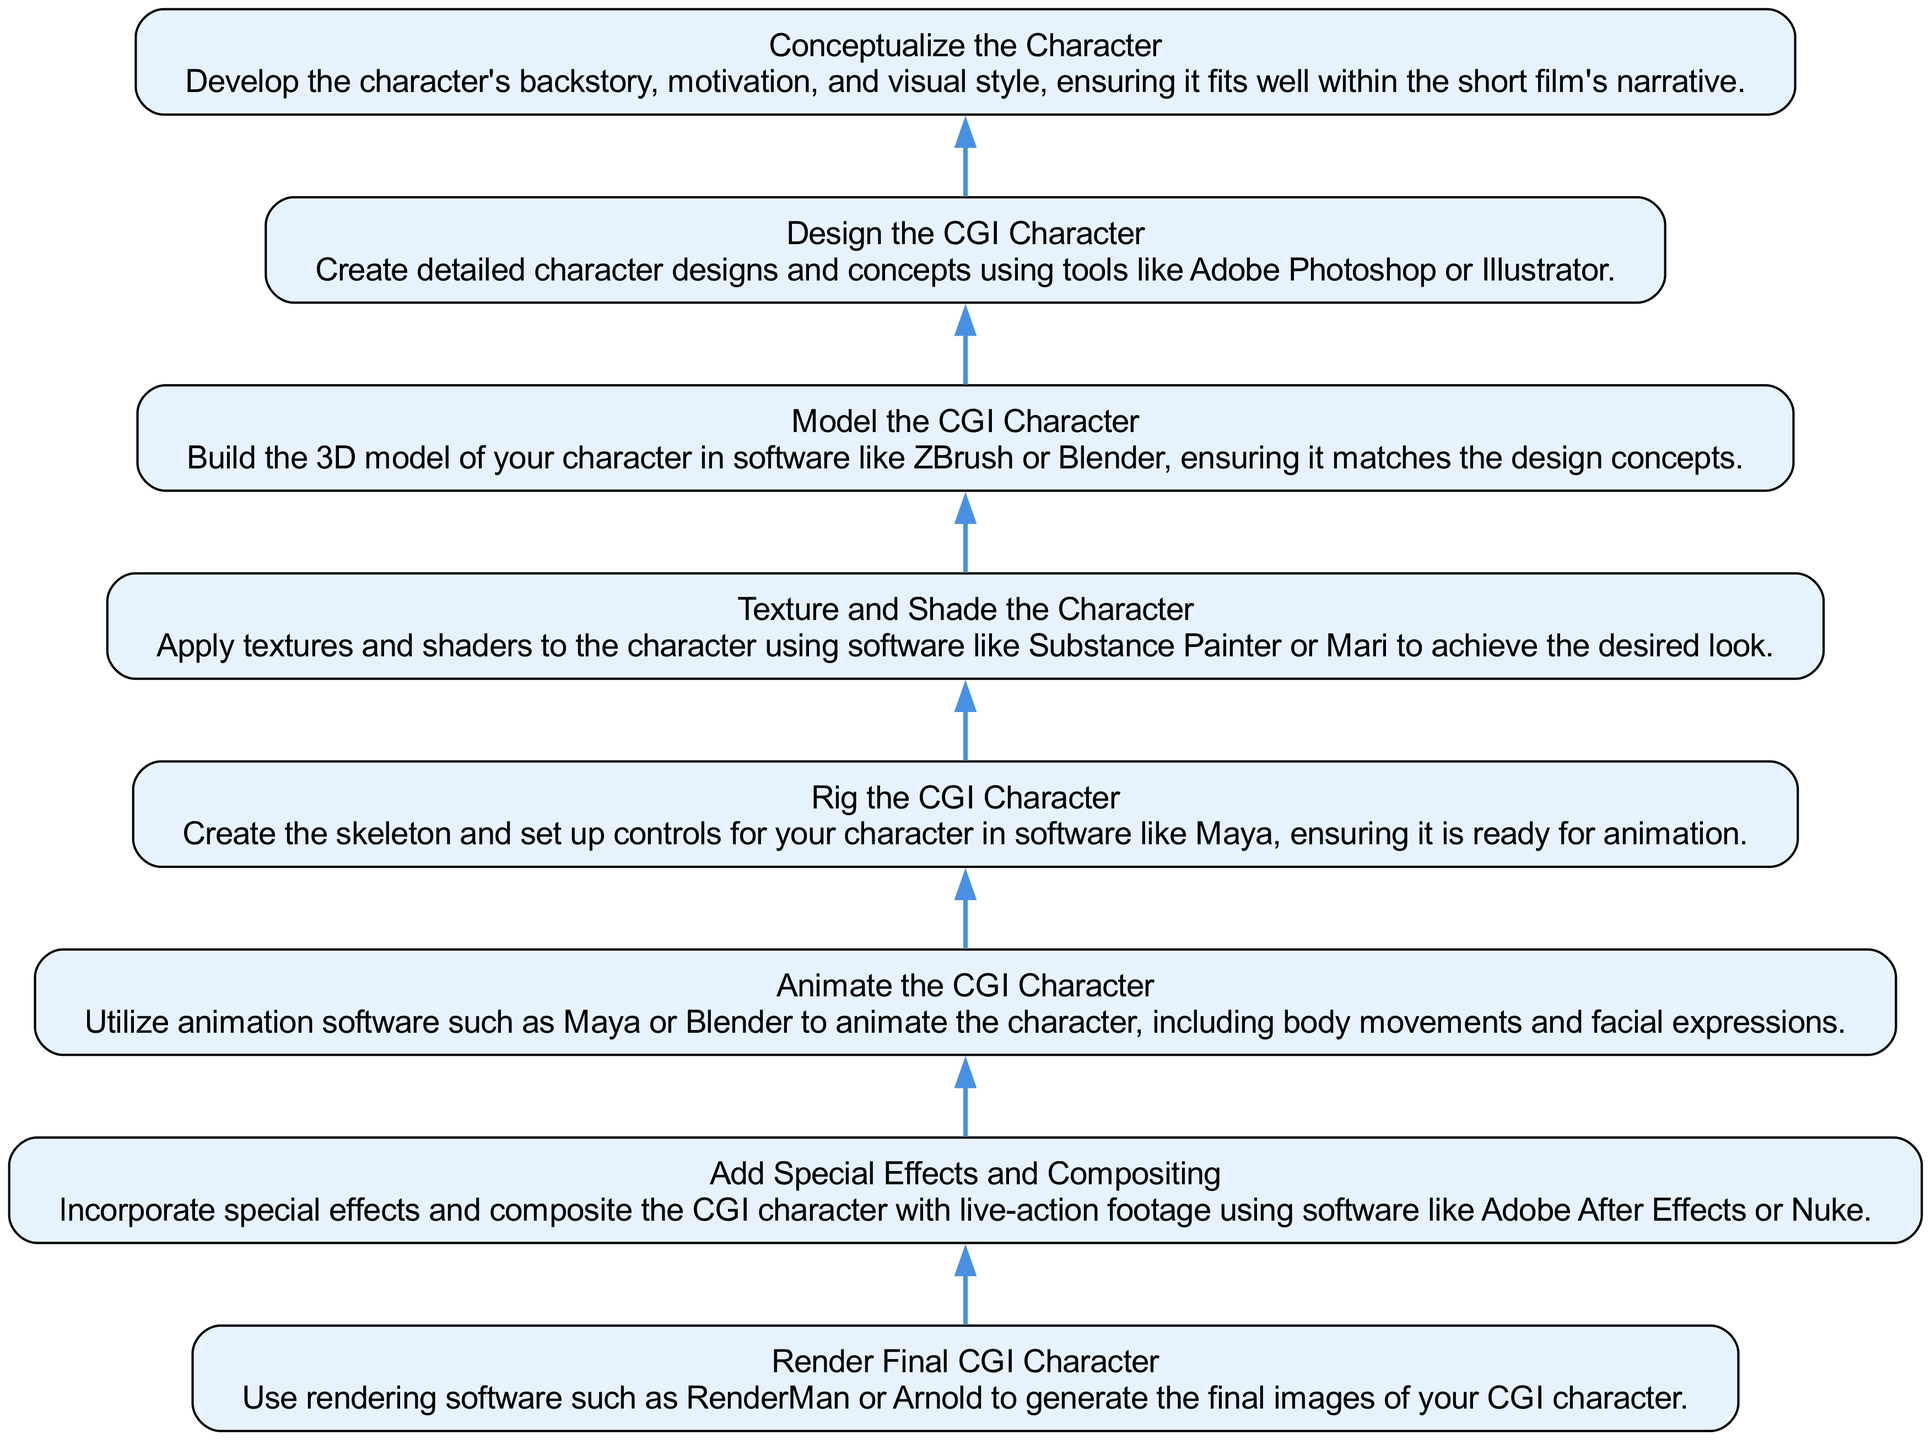What is the first step in creating a CGI character? The first step is conceptualizing the character, which involves developing the backstory, motivation, and visual style. This is the bottom node in the flow chart, providing the initial direction for the process.
Answer: Conceptualize the Character How many steps are involved in creating a CGI character? The diagram features eight steps for creating a CGI character, as each one is represented as a node connected in sequence from bottom to top.
Answer: Eight What software is suggested for rigging the CGI character? The diagram indicates that Maya is the software suggested for rigging the CGI character, as mentioned in the rigging step description.
Answer: Maya What step directly precedes the animation of the CGI character? Rigging the CGI character is the step that directly precedes animation, as it sets up the necessary controls for the character to be animated. By following the flow from bottom to top, we see that animation follows rigging.
Answer: Rig the CGI Character Which step involves applying textures and shaders? The step that involves applying textures and shaders to the character is designated as "Texture and Shade the Character," which comes after modeling but before final rendering.
Answer: Texture and Shade the Character What is the final step in the CGI character creation process? The final step is rendering the final CGI character, where rendering software is used to generate the final images. This is positioned at the top of the flow chart.
Answer: Render Final CGI Character In which step is special effects incorporated? The incorporation of special effects takes place in the "Add Special Effects and Compositing" step, which follows the animation of the character. This step emphasizes blending CGI with live-action footage.
Answer: Add Special Effects and Compositing What is essential before animating the CGI character? Rigging the CGI character is essential before animation since it provides the structure and controls necessary for animating various movements. Without this step, animation cannot effectively proceed.
Answer: Rig the CGI Character 